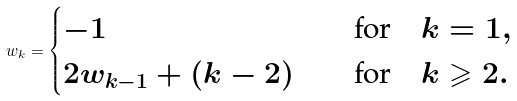<formula> <loc_0><loc_0><loc_500><loc_500>w _ { k } = \begin{cases} - 1 & \text {\quad for\quad } k = 1 , \\ 2 w _ { k - 1 } + ( k - 2 ) & \text {\quad for\quad } k \geqslant 2 . \end{cases}</formula> 